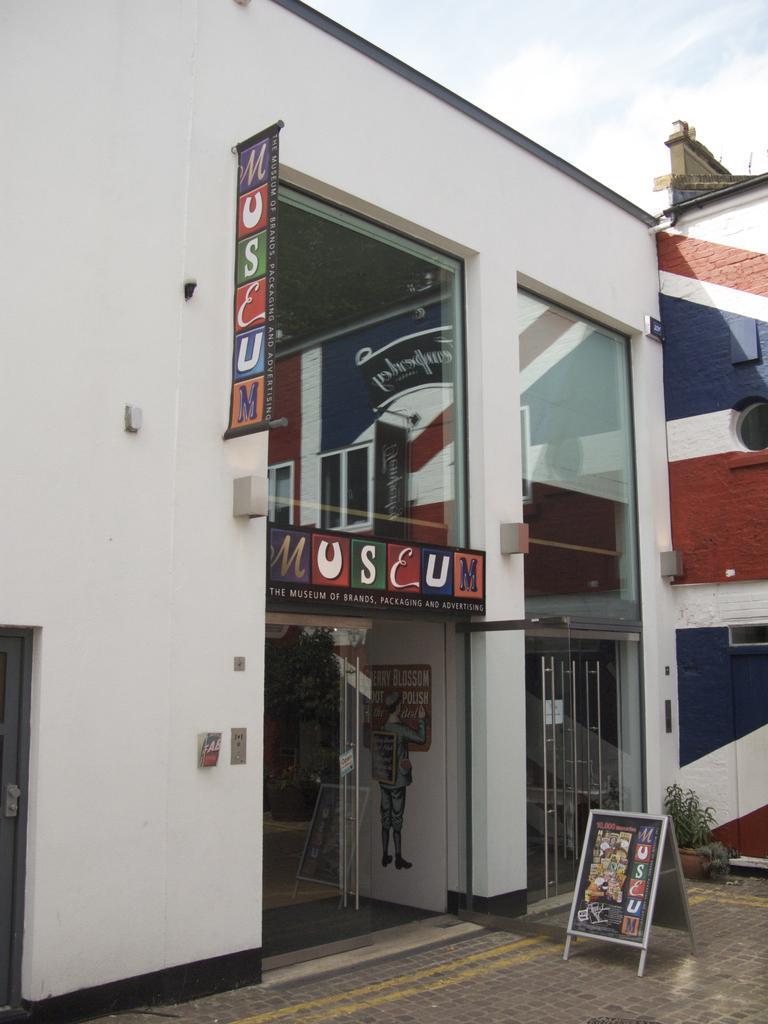Please provide a concise description of this image. In this image, we can see a building which is colored white. There is a board in the bottom right of the image. There is a banner on the wall. There is a sky at the top of the image. 